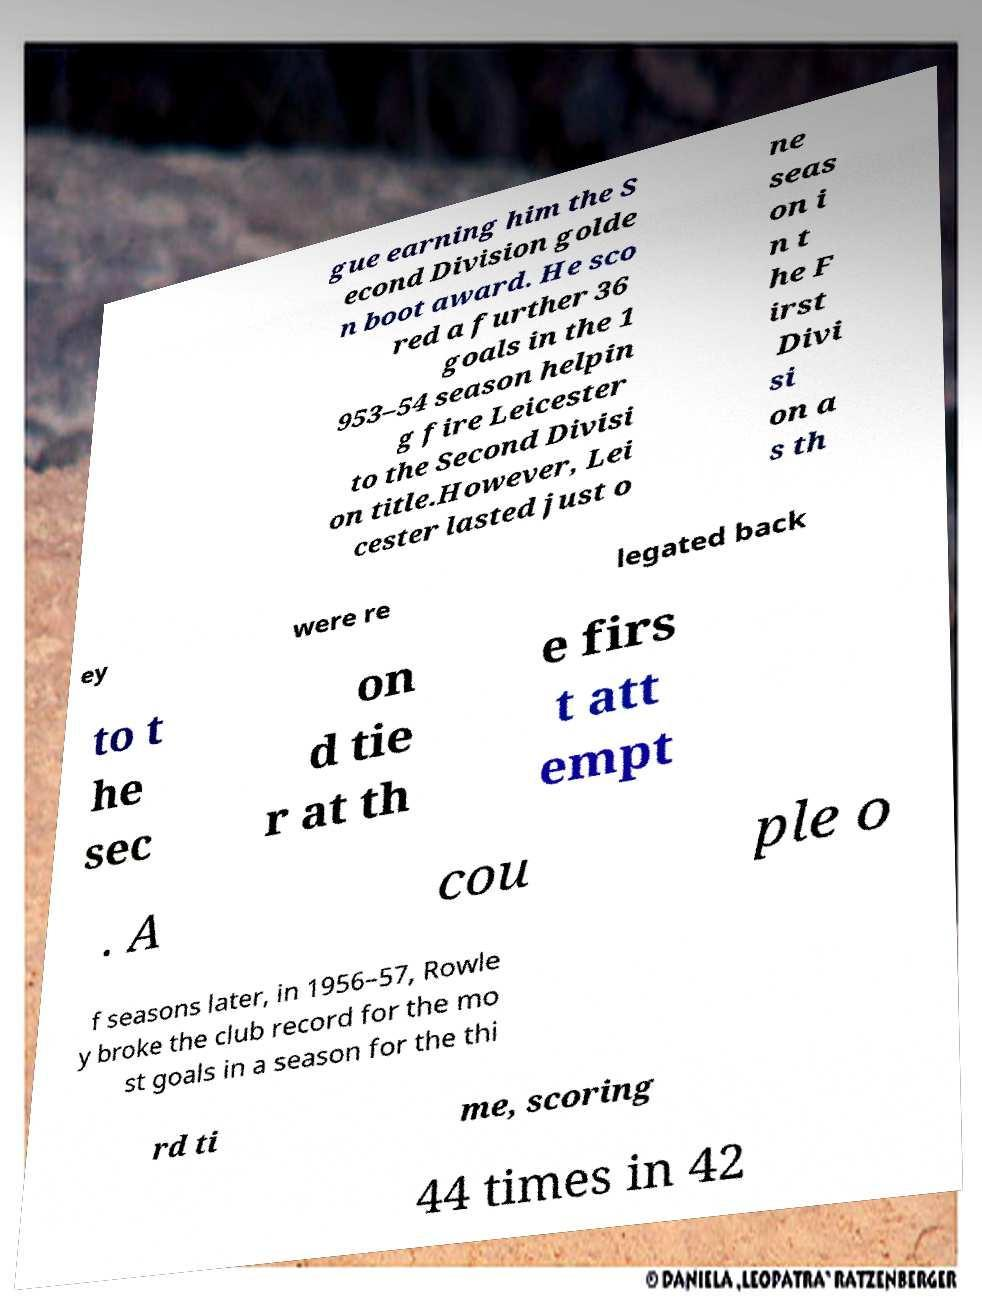Please read and relay the text visible in this image. What does it say? gue earning him the S econd Division golde n boot award. He sco red a further 36 goals in the 1 953–54 season helpin g fire Leicester to the Second Divisi on title.However, Lei cester lasted just o ne seas on i n t he F irst Divi si on a s th ey were re legated back to t he sec on d tie r at th e firs t att empt . A cou ple o f seasons later, in 1956–57, Rowle y broke the club record for the mo st goals in a season for the thi rd ti me, scoring 44 times in 42 